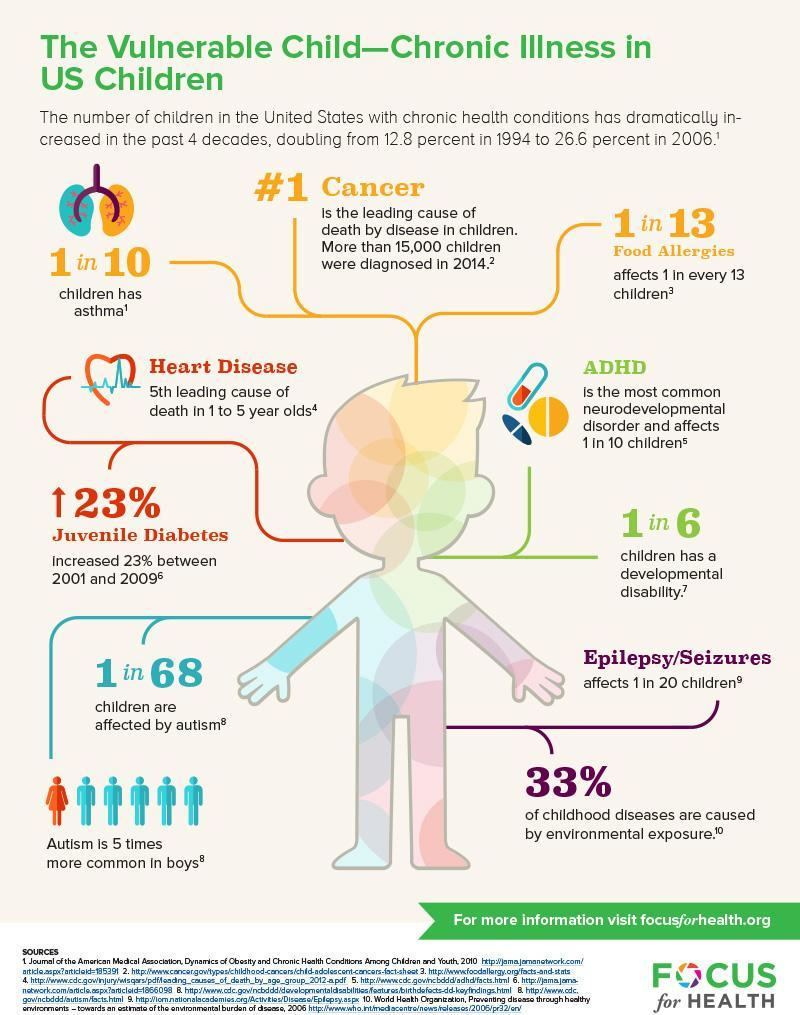Out of 6, how many children have a developmental disability?
Answer the question with a short phrase. 5 What percentage of childhood diseases are not caused by environmental exposure? 67% Out of 10, how many children have no asthma? 9 Out of 68, how many children are not affected by autism? 67 